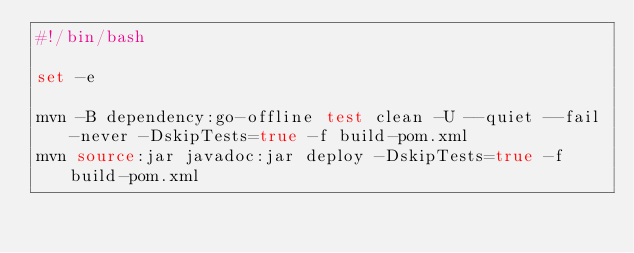Convert code to text. <code><loc_0><loc_0><loc_500><loc_500><_Bash_>#!/bin/bash

set -e

mvn -B dependency:go-offline test clean -U --quiet --fail-never -DskipTests=true -f build-pom.xml
mvn source:jar javadoc:jar deploy -DskipTests=true -f build-pom.xml
</code> 